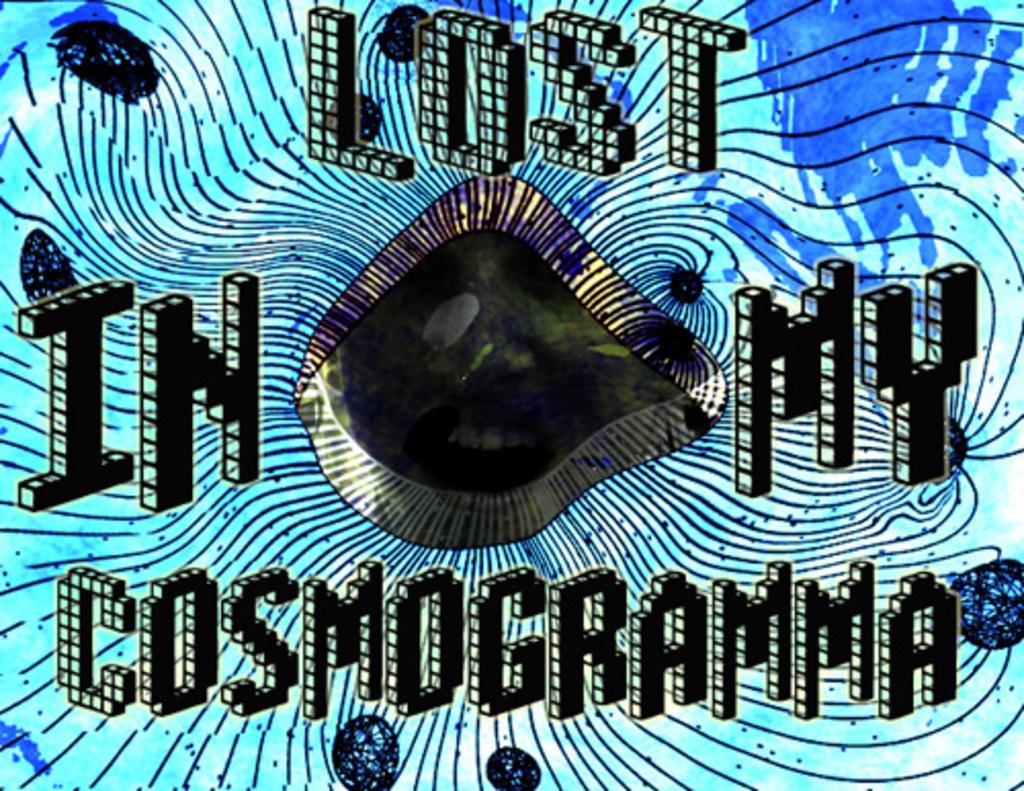Lost in what?
Offer a terse response. My cosmogramma. Isthis a painting?
Your response must be concise. Yes. 